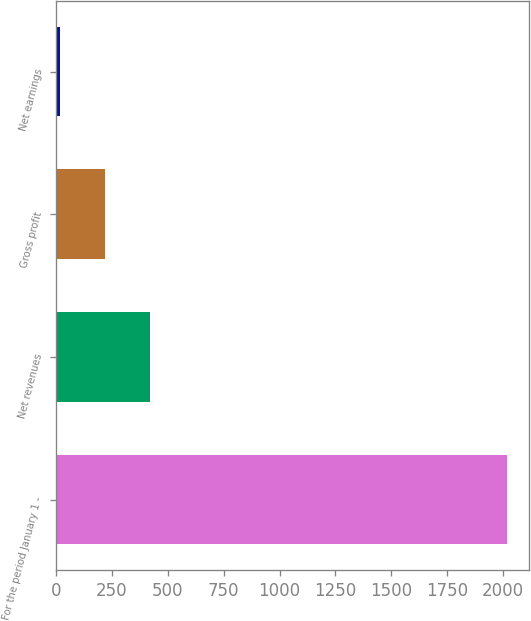Convert chart to OTSL. <chart><loc_0><loc_0><loc_500><loc_500><bar_chart><fcel>For the period January 1 -<fcel>Net revenues<fcel>Gross profit<fcel>Net earnings<nl><fcel>2016<fcel>419.44<fcel>219.87<fcel>20.3<nl></chart> 